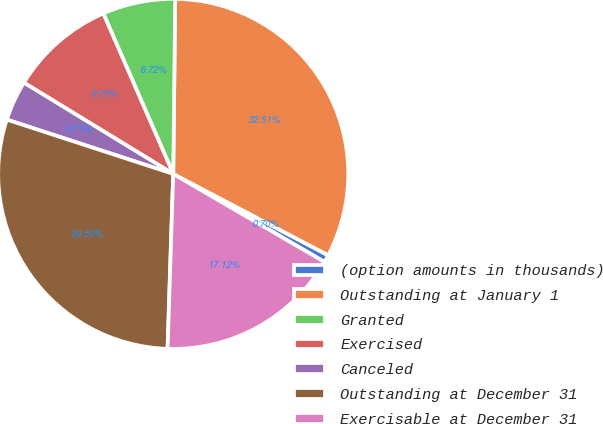<chart> <loc_0><loc_0><loc_500><loc_500><pie_chart><fcel>(option amounts in thousands)<fcel>Outstanding at January 1<fcel>Granted<fcel>Exercised<fcel>Canceled<fcel>Outstanding at December 31<fcel>Exercisable at December 31<nl><fcel>0.7%<fcel>32.51%<fcel>6.72%<fcel>9.73%<fcel>3.71%<fcel>29.5%<fcel>17.12%<nl></chart> 